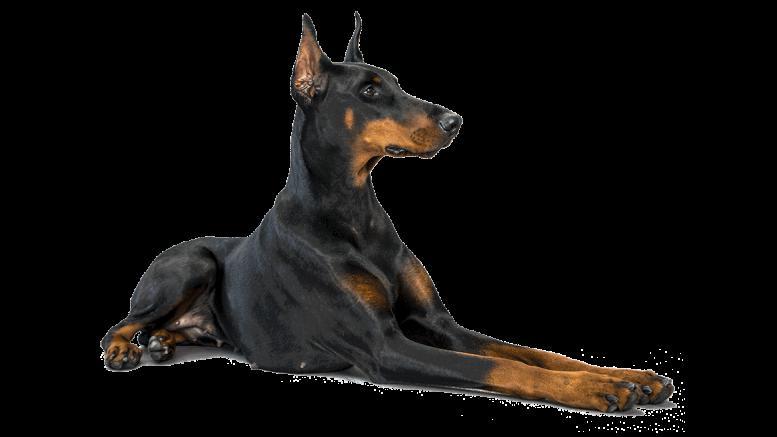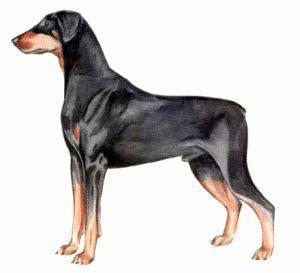The first image is the image on the left, the second image is the image on the right. Analyze the images presented: Is the assertion "The dog in the image on the left is lying down." valid? Answer yes or no. Yes. 